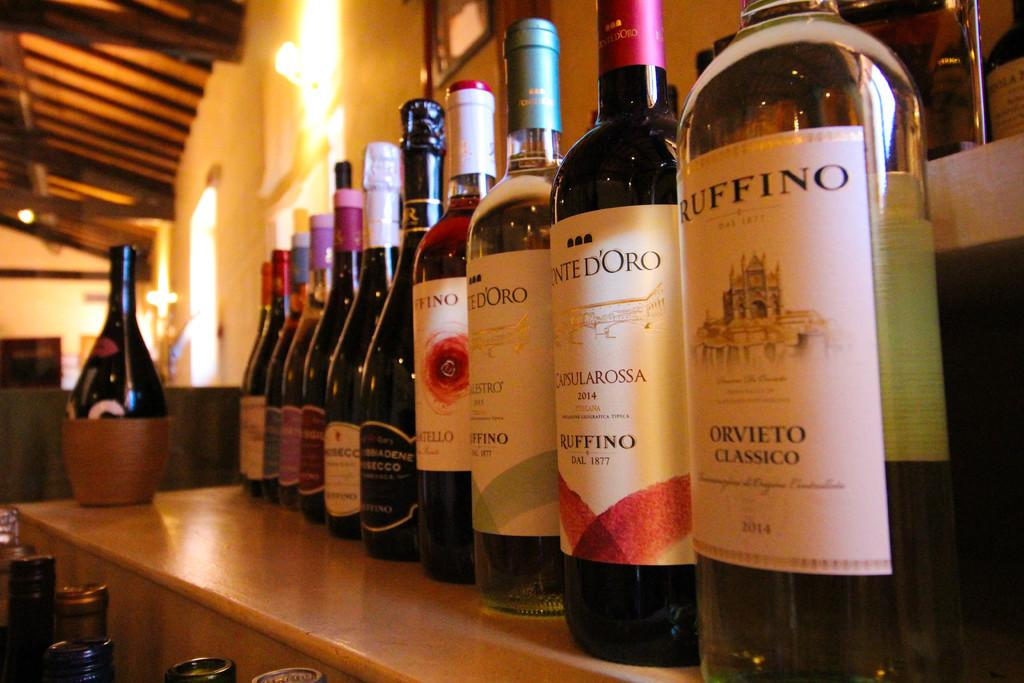What piece of furniture is present in the image? There is a table in the image. What items are on the table? There are alcohol bottles on the table. What can be seen at the top of the image? There is a light on the top of the image. How many cakes are on the table in the image? There are no cakes present in the image; only alcohol bottles are visible on the table. What type of cord is used to power the light in the image? There is no cord visible in the image, as the light appears to be powered by another source or is not powered at all. 